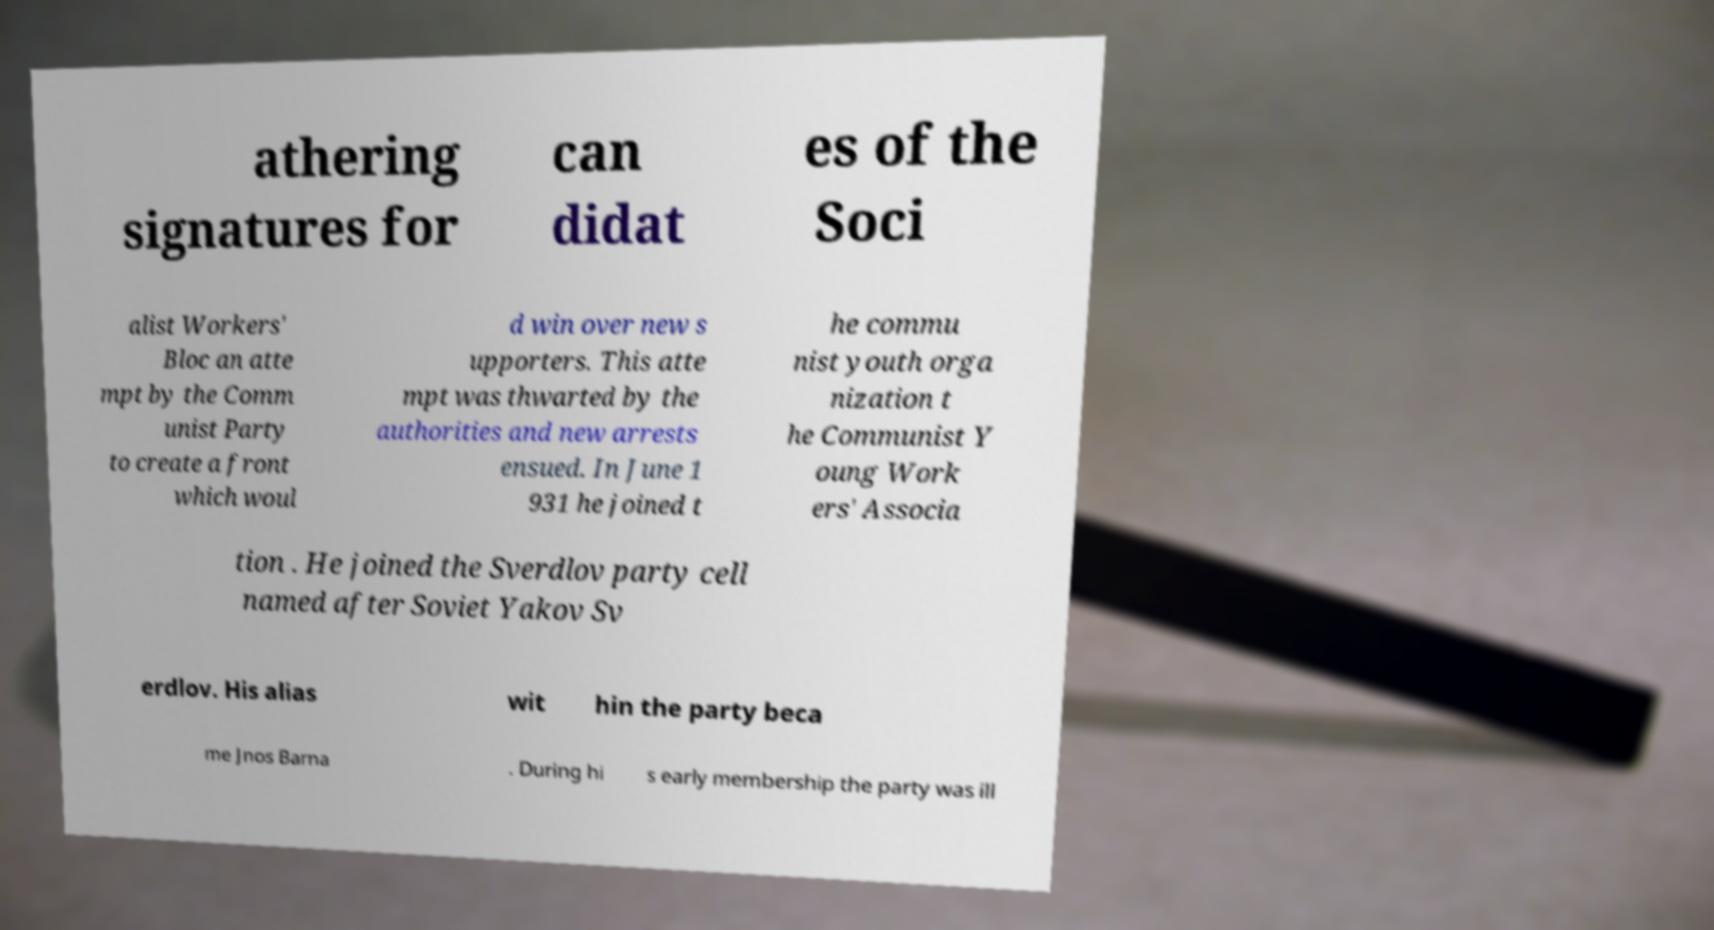What messages or text are displayed in this image? I need them in a readable, typed format. athering signatures for can didat es of the Soci alist Workers' Bloc an atte mpt by the Comm unist Party to create a front which woul d win over new s upporters. This atte mpt was thwarted by the authorities and new arrests ensued. In June 1 931 he joined t he commu nist youth orga nization t he Communist Y oung Work ers' Associa tion . He joined the Sverdlov party cell named after Soviet Yakov Sv erdlov. His alias wit hin the party beca me Jnos Barna . During hi s early membership the party was ill 